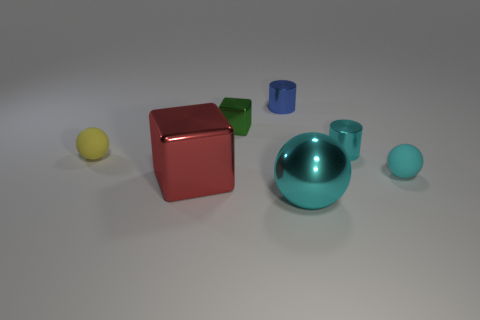Subtract all big cyan balls. How many balls are left? 2 Add 1 small yellow things. How many objects exist? 8 Subtract all brown cylinders. How many cyan spheres are left? 2 Subtract all yellow spheres. How many spheres are left? 2 Subtract all cylinders. How many objects are left? 5 Subtract all gray blocks. Subtract all cyan metal cylinders. How many objects are left? 6 Add 2 red things. How many red things are left? 3 Add 3 red objects. How many red objects exist? 4 Subtract 0 blue blocks. How many objects are left? 7 Subtract 1 spheres. How many spheres are left? 2 